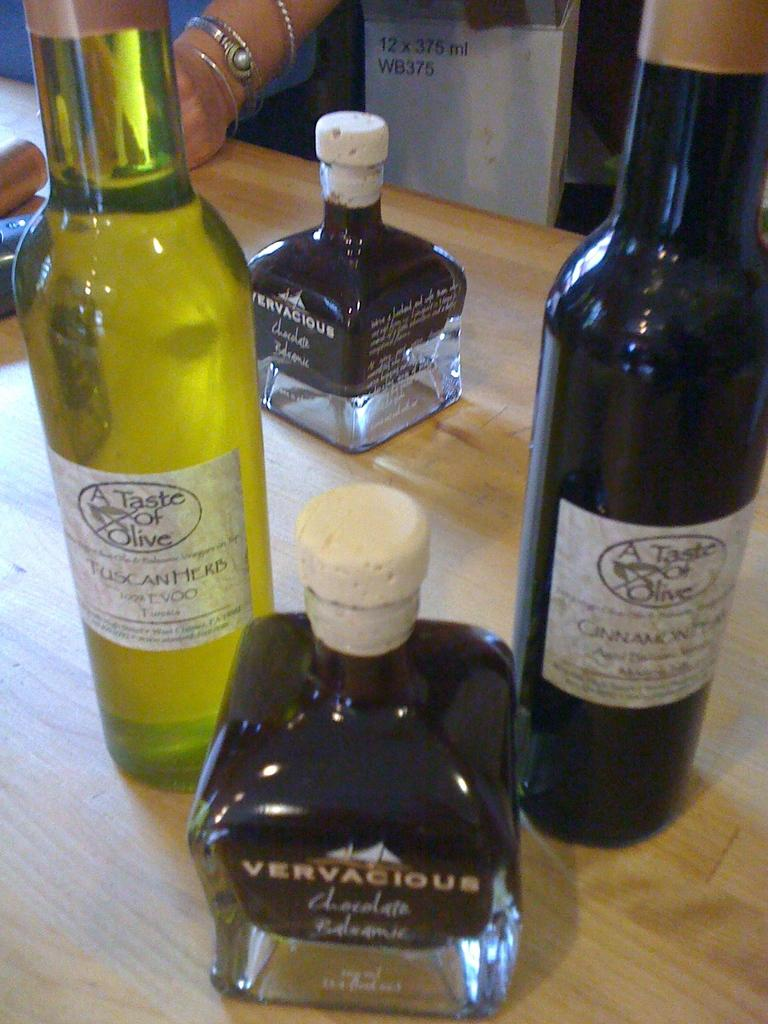What is the main object visible in the image? There is a wine bottle in the image. What else can be seen on the table in the image? There are other objects on the table in the image. What type of plastic fork is being used by the sister in the image? There is no sister or plastic fork present in the image. 